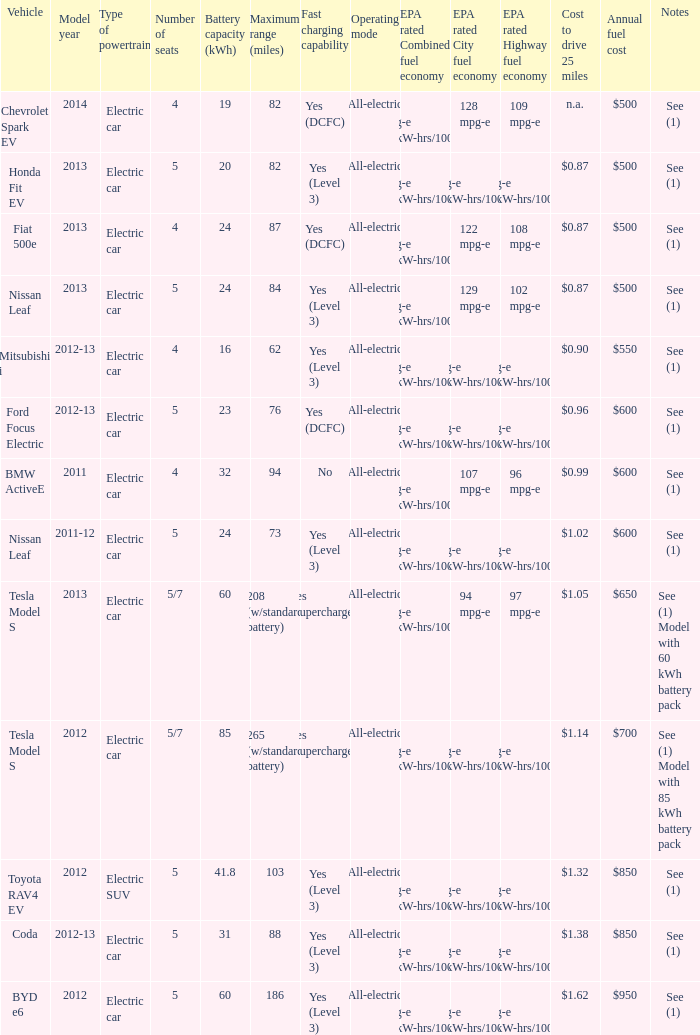What is the epa highway fuel economy for an electric suv? 74 mpg-e (46kW-hrs/100mi). 